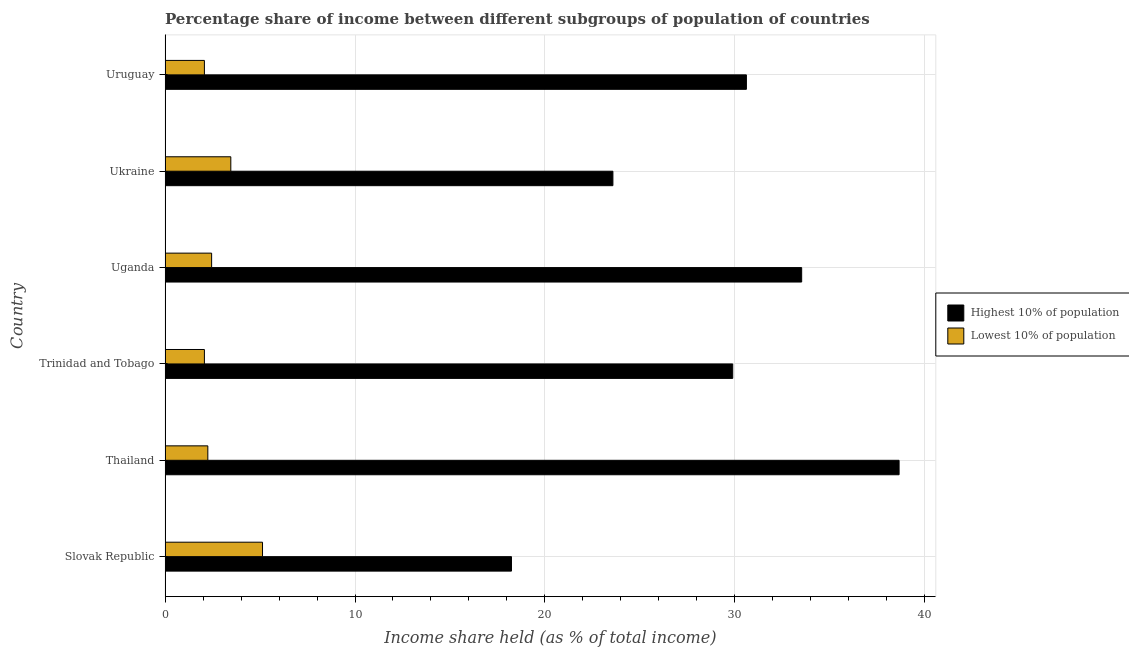How many different coloured bars are there?
Offer a terse response. 2. How many groups of bars are there?
Provide a succinct answer. 6. What is the label of the 3rd group of bars from the top?
Give a very brief answer. Uganda. In how many cases, is the number of bars for a given country not equal to the number of legend labels?
Your answer should be very brief. 0. What is the income share held by highest 10% of the population in Uruguay?
Provide a short and direct response. 30.61. Across all countries, what is the maximum income share held by highest 10% of the population?
Offer a terse response. 38.65. Across all countries, what is the minimum income share held by lowest 10% of the population?
Your answer should be compact. 2.07. In which country was the income share held by highest 10% of the population maximum?
Keep it short and to the point. Thailand. In which country was the income share held by lowest 10% of the population minimum?
Your answer should be compact. Trinidad and Tobago. What is the total income share held by lowest 10% of the population in the graph?
Your answer should be compact. 17.43. What is the difference between the income share held by highest 10% of the population in Ukraine and that in Uruguay?
Your answer should be compact. -7.03. What is the difference between the income share held by highest 10% of the population in Ukraine and the income share held by lowest 10% of the population in Uganda?
Your answer should be compact. 21.13. What is the average income share held by lowest 10% of the population per country?
Your answer should be very brief. 2.9. What is the difference between the income share held by highest 10% of the population and income share held by lowest 10% of the population in Uruguay?
Provide a short and direct response. 28.54. In how many countries, is the income share held by highest 10% of the population greater than 2 %?
Ensure brevity in your answer.  6. What is the ratio of the income share held by highest 10% of the population in Trinidad and Tobago to that in Uganda?
Offer a very short reply. 0.89. What is the difference between the highest and the second highest income share held by lowest 10% of the population?
Provide a short and direct response. 1.67. What is the difference between the highest and the lowest income share held by highest 10% of the population?
Your answer should be compact. 20.41. Is the sum of the income share held by lowest 10% of the population in Trinidad and Tobago and Uruguay greater than the maximum income share held by highest 10% of the population across all countries?
Make the answer very short. No. What does the 2nd bar from the top in Ukraine represents?
Your response must be concise. Highest 10% of population. What does the 2nd bar from the bottom in Thailand represents?
Your answer should be very brief. Lowest 10% of population. How many bars are there?
Your answer should be very brief. 12. Are the values on the major ticks of X-axis written in scientific E-notation?
Offer a terse response. No. Does the graph contain any zero values?
Keep it short and to the point. No. Where does the legend appear in the graph?
Provide a short and direct response. Center right. How are the legend labels stacked?
Make the answer very short. Vertical. What is the title of the graph?
Provide a succinct answer. Percentage share of income between different subgroups of population of countries. What is the label or title of the X-axis?
Keep it short and to the point. Income share held (as % of total income). What is the label or title of the Y-axis?
Your response must be concise. Country. What is the Income share held (as % of total income) of Highest 10% of population in Slovak Republic?
Make the answer very short. 18.24. What is the Income share held (as % of total income) of Lowest 10% of population in Slovak Republic?
Provide a short and direct response. 5.13. What is the Income share held (as % of total income) of Highest 10% of population in Thailand?
Keep it short and to the point. 38.65. What is the Income share held (as % of total income) in Lowest 10% of population in Thailand?
Your response must be concise. 2.25. What is the Income share held (as % of total income) of Highest 10% of population in Trinidad and Tobago?
Make the answer very short. 29.89. What is the Income share held (as % of total income) in Lowest 10% of population in Trinidad and Tobago?
Your response must be concise. 2.07. What is the Income share held (as % of total income) in Highest 10% of population in Uganda?
Give a very brief answer. 33.52. What is the Income share held (as % of total income) in Lowest 10% of population in Uganda?
Make the answer very short. 2.45. What is the Income share held (as % of total income) in Highest 10% of population in Ukraine?
Your answer should be compact. 23.58. What is the Income share held (as % of total income) in Lowest 10% of population in Ukraine?
Ensure brevity in your answer.  3.46. What is the Income share held (as % of total income) in Highest 10% of population in Uruguay?
Your response must be concise. 30.61. What is the Income share held (as % of total income) of Lowest 10% of population in Uruguay?
Offer a terse response. 2.07. Across all countries, what is the maximum Income share held (as % of total income) of Highest 10% of population?
Ensure brevity in your answer.  38.65. Across all countries, what is the maximum Income share held (as % of total income) of Lowest 10% of population?
Make the answer very short. 5.13. Across all countries, what is the minimum Income share held (as % of total income) in Highest 10% of population?
Your answer should be compact. 18.24. Across all countries, what is the minimum Income share held (as % of total income) of Lowest 10% of population?
Offer a terse response. 2.07. What is the total Income share held (as % of total income) in Highest 10% of population in the graph?
Offer a very short reply. 174.49. What is the total Income share held (as % of total income) of Lowest 10% of population in the graph?
Make the answer very short. 17.43. What is the difference between the Income share held (as % of total income) of Highest 10% of population in Slovak Republic and that in Thailand?
Offer a very short reply. -20.41. What is the difference between the Income share held (as % of total income) in Lowest 10% of population in Slovak Republic and that in Thailand?
Make the answer very short. 2.88. What is the difference between the Income share held (as % of total income) of Highest 10% of population in Slovak Republic and that in Trinidad and Tobago?
Provide a succinct answer. -11.65. What is the difference between the Income share held (as % of total income) of Lowest 10% of population in Slovak Republic and that in Trinidad and Tobago?
Ensure brevity in your answer.  3.06. What is the difference between the Income share held (as % of total income) of Highest 10% of population in Slovak Republic and that in Uganda?
Give a very brief answer. -15.28. What is the difference between the Income share held (as % of total income) of Lowest 10% of population in Slovak Republic and that in Uganda?
Your answer should be very brief. 2.68. What is the difference between the Income share held (as % of total income) of Highest 10% of population in Slovak Republic and that in Ukraine?
Make the answer very short. -5.34. What is the difference between the Income share held (as % of total income) of Lowest 10% of population in Slovak Republic and that in Ukraine?
Your response must be concise. 1.67. What is the difference between the Income share held (as % of total income) in Highest 10% of population in Slovak Republic and that in Uruguay?
Offer a terse response. -12.37. What is the difference between the Income share held (as % of total income) of Lowest 10% of population in Slovak Republic and that in Uruguay?
Your response must be concise. 3.06. What is the difference between the Income share held (as % of total income) of Highest 10% of population in Thailand and that in Trinidad and Tobago?
Give a very brief answer. 8.76. What is the difference between the Income share held (as % of total income) in Lowest 10% of population in Thailand and that in Trinidad and Tobago?
Provide a short and direct response. 0.18. What is the difference between the Income share held (as % of total income) of Highest 10% of population in Thailand and that in Uganda?
Provide a short and direct response. 5.13. What is the difference between the Income share held (as % of total income) of Lowest 10% of population in Thailand and that in Uganda?
Your response must be concise. -0.2. What is the difference between the Income share held (as % of total income) in Highest 10% of population in Thailand and that in Ukraine?
Provide a succinct answer. 15.07. What is the difference between the Income share held (as % of total income) of Lowest 10% of population in Thailand and that in Ukraine?
Your answer should be very brief. -1.21. What is the difference between the Income share held (as % of total income) in Highest 10% of population in Thailand and that in Uruguay?
Provide a succinct answer. 8.04. What is the difference between the Income share held (as % of total income) of Lowest 10% of population in Thailand and that in Uruguay?
Your answer should be very brief. 0.18. What is the difference between the Income share held (as % of total income) in Highest 10% of population in Trinidad and Tobago and that in Uganda?
Offer a terse response. -3.63. What is the difference between the Income share held (as % of total income) of Lowest 10% of population in Trinidad and Tobago and that in Uganda?
Your answer should be compact. -0.38. What is the difference between the Income share held (as % of total income) of Highest 10% of population in Trinidad and Tobago and that in Ukraine?
Keep it short and to the point. 6.31. What is the difference between the Income share held (as % of total income) of Lowest 10% of population in Trinidad and Tobago and that in Ukraine?
Make the answer very short. -1.39. What is the difference between the Income share held (as % of total income) of Highest 10% of population in Trinidad and Tobago and that in Uruguay?
Make the answer very short. -0.72. What is the difference between the Income share held (as % of total income) of Highest 10% of population in Uganda and that in Ukraine?
Your answer should be compact. 9.94. What is the difference between the Income share held (as % of total income) of Lowest 10% of population in Uganda and that in Ukraine?
Your answer should be very brief. -1.01. What is the difference between the Income share held (as % of total income) of Highest 10% of population in Uganda and that in Uruguay?
Keep it short and to the point. 2.91. What is the difference between the Income share held (as % of total income) in Lowest 10% of population in Uganda and that in Uruguay?
Offer a very short reply. 0.38. What is the difference between the Income share held (as % of total income) in Highest 10% of population in Ukraine and that in Uruguay?
Your answer should be compact. -7.03. What is the difference between the Income share held (as % of total income) in Lowest 10% of population in Ukraine and that in Uruguay?
Your response must be concise. 1.39. What is the difference between the Income share held (as % of total income) of Highest 10% of population in Slovak Republic and the Income share held (as % of total income) of Lowest 10% of population in Thailand?
Make the answer very short. 15.99. What is the difference between the Income share held (as % of total income) in Highest 10% of population in Slovak Republic and the Income share held (as % of total income) in Lowest 10% of population in Trinidad and Tobago?
Your answer should be compact. 16.17. What is the difference between the Income share held (as % of total income) of Highest 10% of population in Slovak Republic and the Income share held (as % of total income) of Lowest 10% of population in Uganda?
Ensure brevity in your answer.  15.79. What is the difference between the Income share held (as % of total income) in Highest 10% of population in Slovak Republic and the Income share held (as % of total income) in Lowest 10% of population in Ukraine?
Offer a very short reply. 14.78. What is the difference between the Income share held (as % of total income) in Highest 10% of population in Slovak Republic and the Income share held (as % of total income) in Lowest 10% of population in Uruguay?
Offer a very short reply. 16.17. What is the difference between the Income share held (as % of total income) in Highest 10% of population in Thailand and the Income share held (as % of total income) in Lowest 10% of population in Trinidad and Tobago?
Your response must be concise. 36.58. What is the difference between the Income share held (as % of total income) in Highest 10% of population in Thailand and the Income share held (as % of total income) in Lowest 10% of population in Uganda?
Make the answer very short. 36.2. What is the difference between the Income share held (as % of total income) of Highest 10% of population in Thailand and the Income share held (as % of total income) of Lowest 10% of population in Ukraine?
Keep it short and to the point. 35.19. What is the difference between the Income share held (as % of total income) of Highest 10% of population in Thailand and the Income share held (as % of total income) of Lowest 10% of population in Uruguay?
Give a very brief answer. 36.58. What is the difference between the Income share held (as % of total income) in Highest 10% of population in Trinidad and Tobago and the Income share held (as % of total income) in Lowest 10% of population in Uganda?
Give a very brief answer. 27.44. What is the difference between the Income share held (as % of total income) in Highest 10% of population in Trinidad and Tobago and the Income share held (as % of total income) in Lowest 10% of population in Ukraine?
Provide a short and direct response. 26.43. What is the difference between the Income share held (as % of total income) of Highest 10% of population in Trinidad and Tobago and the Income share held (as % of total income) of Lowest 10% of population in Uruguay?
Provide a succinct answer. 27.82. What is the difference between the Income share held (as % of total income) of Highest 10% of population in Uganda and the Income share held (as % of total income) of Lowest 10% of population in Ukraine?
Provide a short and direct response. 30.06. What is the difference between the Income share held (as % of total income) of Highest 10% of population in Uganda and the Income share held (as % of total income) of Lowest 10% of population in Uruguay?
Offer a very short reply. 31.45. What is the difference between the Income share held (as % of total income) of Highest 10% of population in Ukraine and the Income share held (as % of total income) of Lowest 10% of population in Uruguay?
Ensure brevity in your answer.  21.51. What is the average Income share held (as % of total income) of Highest 10% of population per country?
Offer a terse response. 29.08. What is the average Income share held (as % of total income) of Lowest 10% of population per country?
Offer a terse response. 2.9. What is the difference between the Income share held (as % of total income) in Highest 10% of population and Income share held (as % of total income) in Lowest 10% of population in Slovak Republic?
Provide a short and direct response. 13.11. What is the difference between the Income share held (as % of total income) of Highest 10% of population and Income share held (as % of total income) of Lowest 10% of population in Thailand?
Offer a very short reply. 36.4. What is the difference between the Income share held (as % of total income) in Highest 10% of population and Income share held (as % of total income) in Lowest 10% of population in Trinidad and Tobago?
Make the answer very short. 27.82. What is the difference between the Income share held (as % of total income) in Highest 10% of population and Income share held (as % of total income) in Lowest 10% of population in Uganda?
Provide a short and direct response. 31.07. What is the difference between the Income share held (as % of total income) of Highest 10% of population and Income share held (as % of total income) of Lowest 10% of population in Ukraine?
Make the answer very short. 20.12. What is the difference between the Income share held (as % of total income) in Highest 10% of population and Income share held (as % of total income) in Lowest 10% of population in Uruguay?
Provide a succinct answer. 28.54. What is the ratio of the Income share held (as % of total income) in Highest 10% of population in Slovak Republic to that in Thailand?
Provide a succinct answer. 0.47. What is the ratio of the Income share held (as % of total income) in Lowest 10% of population in Slovak Republic to that in Thailand?
Your answer should be very brief. 2.28. What is the ratio of the Income share held (as % of total income) of Highest 10% of population in Slovak Republic to that in Trinidad and Tobago?
Offer a very short reply. 0.61. What is the ratio of the Income share held (as % of total income) in Lowest 10% of population in Slovak Republic to that in Trinidad and Tobago?
Your answer should be very brief. 2.48. What is the ratio of the Income share held (as % of total income) in Highest 10% of population in Slovak Republic to that in Uganda?
Offer a terse response. 0.54. What is the ratio of the Income share held (as % of total income) of Lowest 10% of population in Slovak Republic to that in Uganda?
Your answer should be very brief. 2.09. What is the ratio of the Income share held (as % of total income) in Highest 10% of population in Slovak Republic to that in Ukraine?
Keep it short and to the point. 0.77. What is the ratio of the Income share held (as % of total income) in Lowest 10% of population in Slovak Republic to that in Ukraine?
Your answer should be compact. 1.48. What is the ratio of the Income share held (as % of total income) of Highest 10% of population in Slovak Republic to that in Uruguay?
Keep it short and to the point. 0.6. What is the ratio of the Income share held (as % of total income) of Lowest 10% of population in Slovak Republic to that in Uruguay?
Offer a terse response. 2.48. What is the ratio of the Income share held (as % of total income) of Highest 10% of population in Thailand to that in Trinidad and Tobago?
Ensure brevity in your answer.  1.29. What is the ratio of the Income share held (as % of total income) in Lowest 10% of population in Thailand to that in Trinidad and Tobago?
Offer a very short reply. 1.09. What is the ratio of the Income share held (as % of total income) in Highest 10% of population in Thailand to that in Uganda?
Offer a very short reply. 1.15. What is the ratio of the Income share held (as % of total income) in Lowest 10% of population in Thailand to that in Uganda?
Keep it short and to the point. 0.92. What is the ratio of the Income share held (as % of total income) in Highest 10% of population in Thailand to that in Ukraine?
Make the answer very short. 1.64. What is the ratio of the Income share held (as % of total income) of Lowest 10% of population in Thailand to that in Ukraine?
Your answer should be compact. 0.65. What is the ratio of the Income share held (as % of total income) of Highest 10% of population in Thailand to that in Uruguay?
Your response must be concise. 1.26. What is the ratio of the Income share held (as % of total income) of Lowest 10% of population in Thailand to that in Uruguay?
Your answer should be compact. 1.09. What is the ratio of the Income share held (as % of total income) of Highest 10% of population in Trinidad and Tobago to that in Uganda?
Ensure brevity in your answer.  0.89. What is the ratio of the Income share held (as % of total income) in Lowest 10% of population in Trinidad and Tobago to that in Uganda?
Provide a short and direct response. 0.84. What is the ratio of the Income share held (as % of total income) in Highest 10% of population in Trinidad and Tobago to that in Ukraine?
Your answer should be compact. 1.27. What is the ratio of the Income share held (as % of total income) in Lowest 10% of population in Trinidad and Tobago to that in Ukraine?
Keep it short and to the point. 0.6. What is the ratio of the Income share held (as % of total income) of Highest 10% of population in Trinidad and Tobago to that in Uruguay?
Your response must be concise. 0.98. What is the ratio of the Income share held (as % of total income) of Highest 10% of population in Uganda to that in Ukraine?
Provide a succinct answer. 1.42. What is the ratio of the Income share held (as % of total income) of Lowest 10% of population in Uganda to that in Ukraine?
Offer a very short reply. 0.71. What is the ratio of the Income share held (as % of total income) of Highest 10% of population in Uganda to that in Uruguay?
Provide a succinct answer. 1.1. What is the ratio of the Income share held (as % of total income) in Lowest 10% of population in Uganda to that in Uruguay?
Provide a short and direct response. 1.18. What is the ratio of the Income share held (as % of total income) in Highest 10% of population in Ukraine to that in Uruguay?
Keep it short and to the point. 0.77. What is the ratio of the Income share held (as % of total income) of Lowest 10% of population in Ukraine to that in Uruguay?
Ensure brevity in your answer.  1.67. What is the difference between the highest and the second highest Income share held (as % of total income) of Highest 10% of population?
Make the answer very short. 5.13. What is the difference between the highest and the second highest Income share held (as % of total income) of Lowest 10% of population?
Offer a very short reply. 1.67. What is the difference between the highest and the lowest Income share held (as % of total income) of Highest 10% of population?
Offer a very short reply. 20.41. What is the difference between the highest and the lowest Income share held (as % of total income) in Lowest 10% of population?
Make the answer very short. 3.06. 